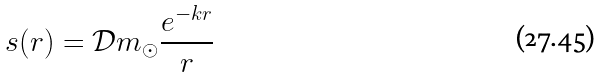Convert formula to latex. <formula><loc_0><loc_0><loc_500><loc_500>s ( r ) = { \mathcal { D } } m _ { \odot } \frac { e ^ { - k r } } { r }</formula> 